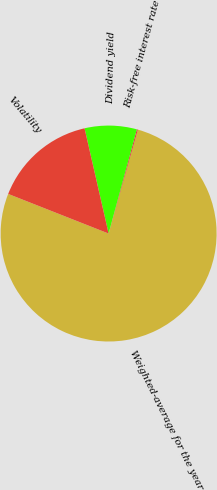Convert chart to OTSL. <chart><loc_0><loc_0><loc_500><loc_500><pie_chart><fcel>Weighted-average for the year<fcel>Risk-free interest rate<fcel>Dividend yield<fcel>Volatility<nl><fcel>76.62%<fcel>0.15%<fcel>7.79%<fcel>15.44%<nl></chart> 